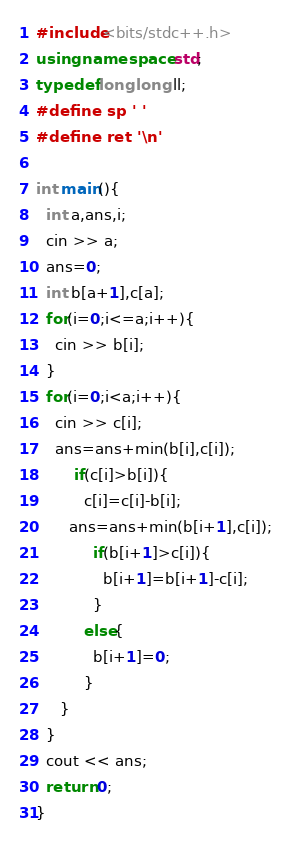Convert code to text. <code><loc_0><loc_0><loc_500><loc_500><_C++_>#include<bits/stdc++.h>
using namespace std;
typedef long long ll;
#define sp ' '
#define ret '\n'

int main(){
  int a,ans,i;
  cin >> a;
  ans=0;
  int b[a+1],c[a];
  for(i=0;i<=a;i++){
    cin >> b[i];
  }
  for(i=0;i<a;i++){
    cin >> c[i];
    ans=ans+min(b[i],c[i]);
    	if(c[i]>b[i]){
    	  c[i]=c[i]-b[i];
   	   ans=ans+min(b[i+1],c[i]);
          	if(b[i+1]>c[i]){
              b[i+1]=b[i+1]-c[i];
            }
          else{
            b[i+1]=0;
          }
   	 }
  }
  cout << ans;
  return 0;
}</code> 